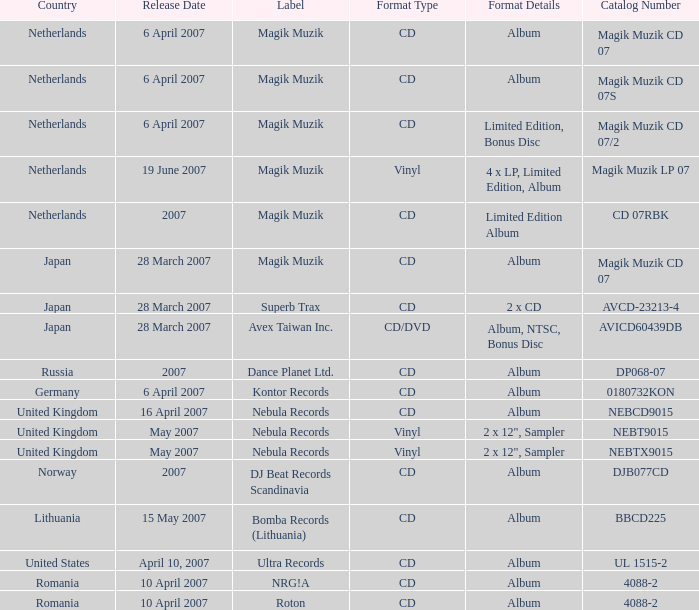For the catalog title DP068-07, what formats are available? CD , Album. 